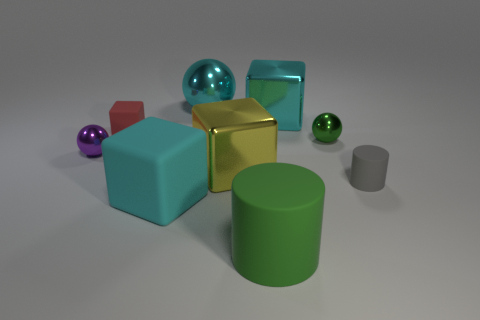Subtract 1 blocks. How many blocks are left? 3 Add 1 blue rubber objects. How many objects exist? 10 Subtract all cubes. How many objects are left? 5 Add 6 big balls. How many big balls are left? 7 Add 3 gray matte cylinders. How many gray matte cylinders exist? 4 Subtract 0 red cylinders. How many objects are left? 9 Subtract all gray objects. Subtract all small green balls. How many objects are left? 7 